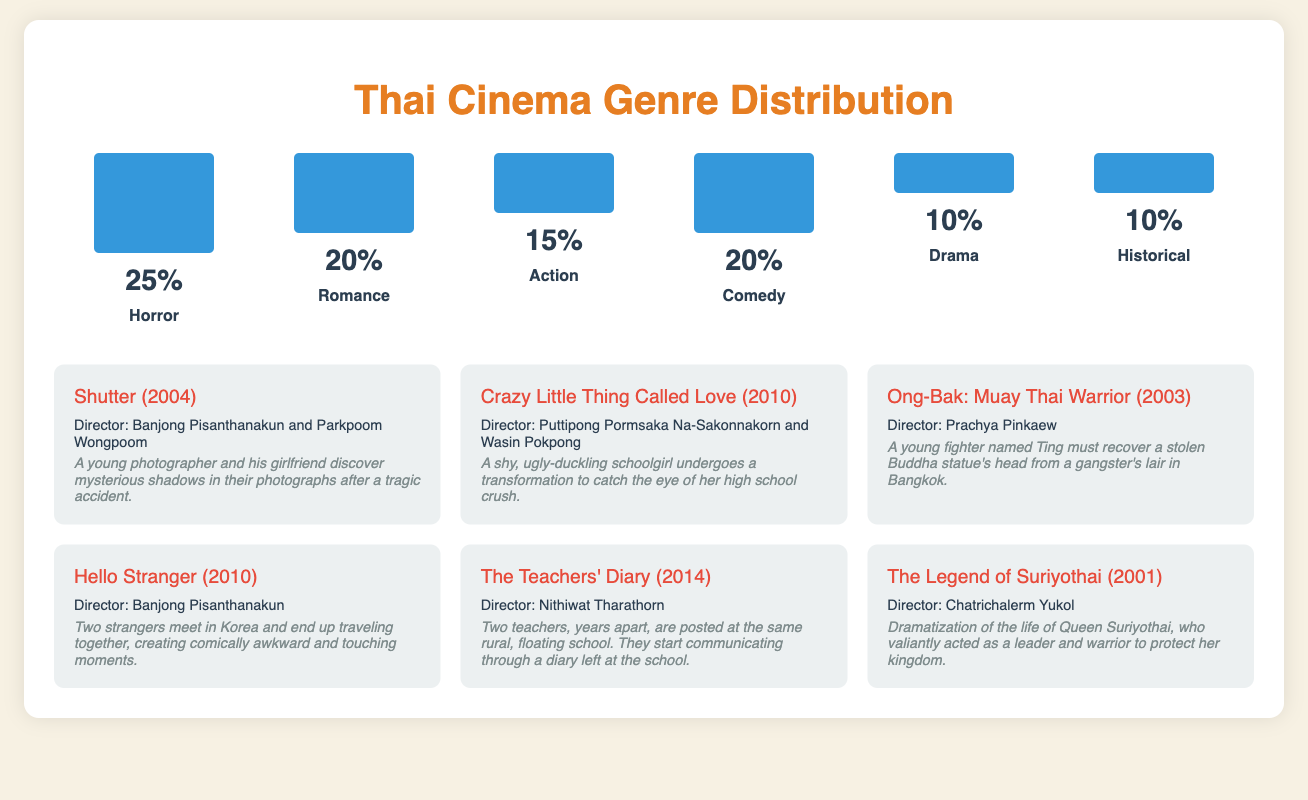What is the most popular genre in Thai cinema? The genre with the highest percentage in the document is Horror, which has a percentage of 25%.
Answer: Horror What percentage of Thai films are classified as Romance? The document states that Romance occupies 20% of the genre distribution in Thai cinema.
Answer: 20% How many genres are represented in the scorecard? The document lists six different genres in Thai cinema.
Answer: 6 What is the title of the film directed by Banjong Pisanthanakun? According to the document, Shutter (2004) and Hello Stranger (2010) are both directed by Banjong Pisanthanakun.
Answer: Shutter (2004) and Hello Stranger (2010) What genre does the film "Ong-Bak: Muay Thai Warrior" belong to? The document categorizes this film within the Action genre.
Answer: Action What is the release year of "The Legend of Suriyothai"? According to the document, "The Legend of Suriyothai" was released in 2001.
Answer: 2001 